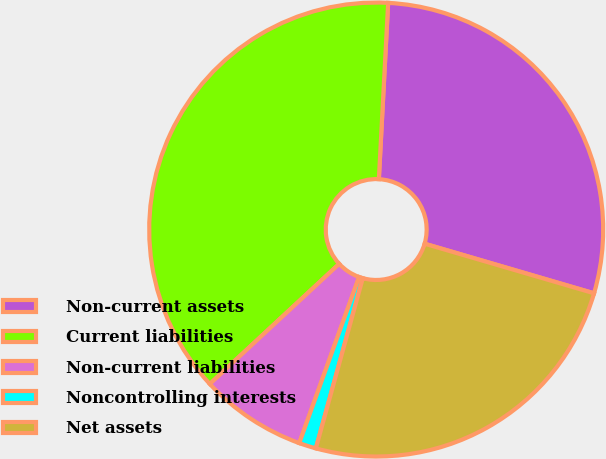Convert chart. <chart><loc_0><loc_0><loc_500><loc_500><pie_chart><fcel>Non-current assets<fcel>Current liabilities<fcel>Non-current liabilities<fcel>Noncontrolling interests<fcel>Net assets<nl><fcel>28.69%<fcel>37.74%<fcel>7.59%<fcel>1.22%<fcel>24.75%<nl></chart> 